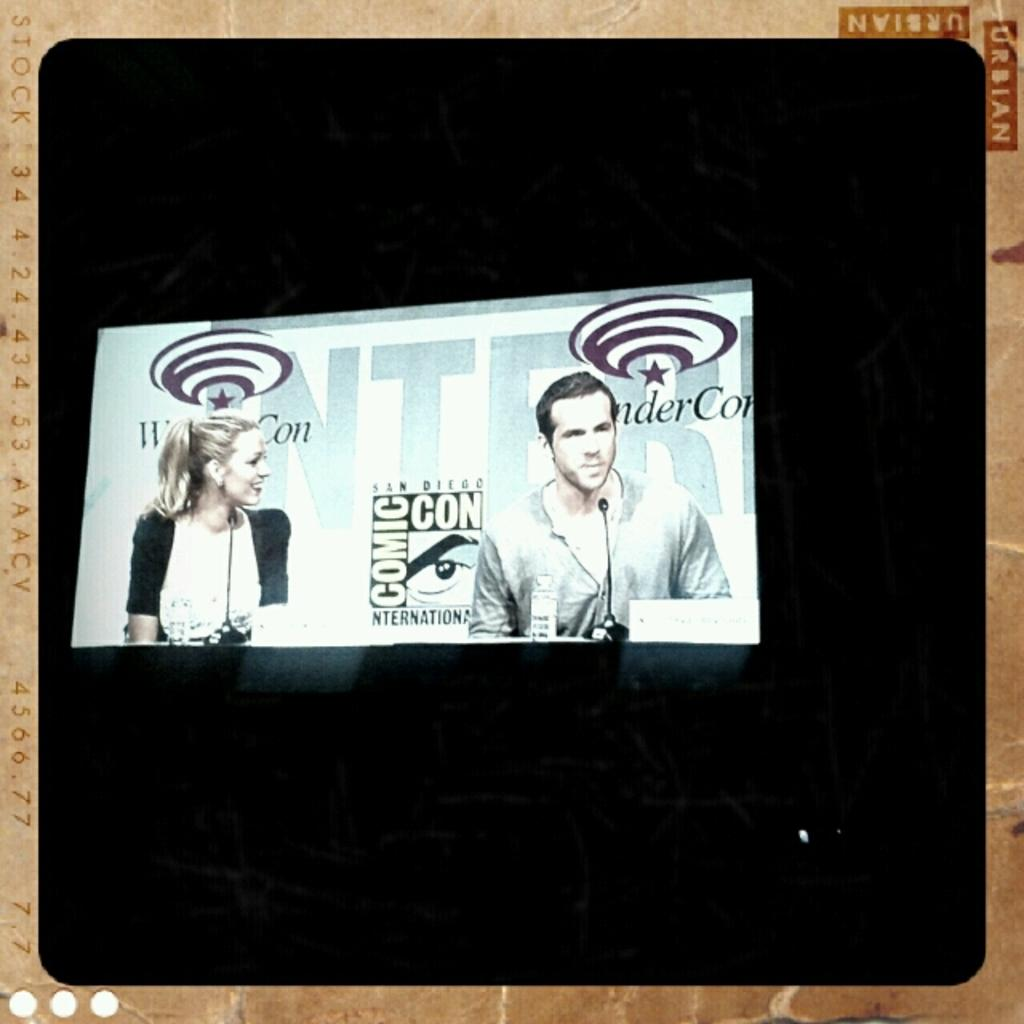What object is present in the image that typically holds a photo? There is a photo frame in the image. What can be seen inside the photo frame? The photo frame contains a photo of a man and a woman. What are the man and woman doing in the photo? The man and woman are sitting in the photo. What piece of furniture is visible in the image? There is a desk in the image. What items are on the desk? There are microphones on the desk. Who delivered the parcel to the man and woman in the photo? There is no parcel or delivery mentioned in the image; it only shows a photo of a man and a woman sitting. What statement does the stranger make to the man and woman in the photo? There is no stranger or statement present in the image; it only shows a photo of a man and a woman sitting. 